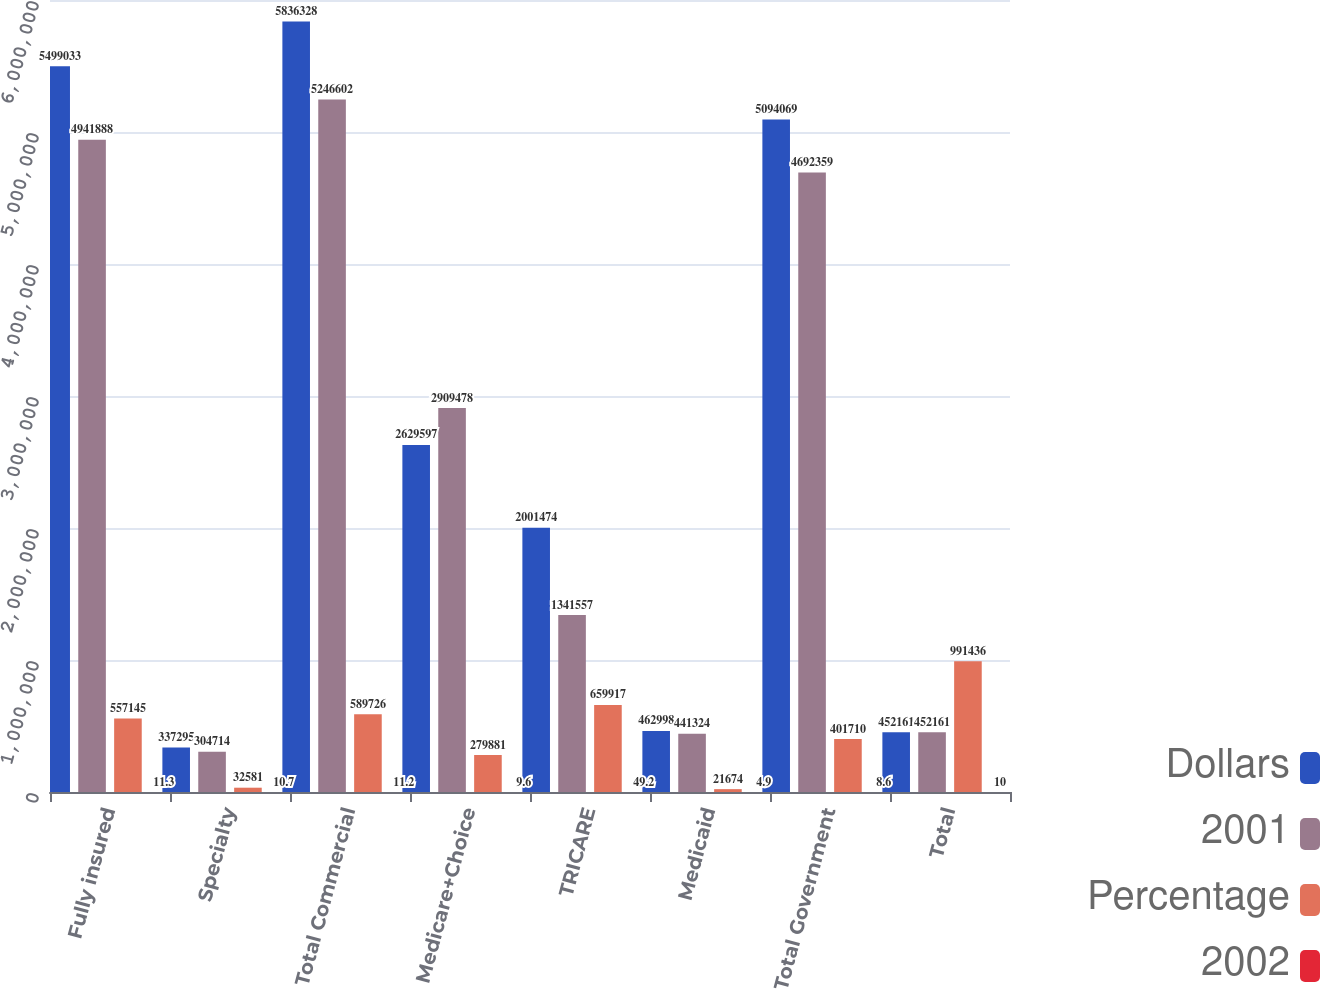Convert chart. <chart><loc_0><loc_0><loc_500><loc_500><stacked_bar_chart><ecel><fcel>Fully insured<fcel>Specialty<fcel>Total Commercial<fcel>Medicare+Choice<fcel>TRICARE<fcel>Medicaid<fcel>Total Government<fcel>Total<nl><fcel>Dollars<fcel>5.49903e+06<fcel>337295<fcel>5.83633e+06<fcel>2.6296e+06<fcel>2.00147e+06<fcel>462998<fcel>5.09407e+06<fcel>452161<nl><fcel>2001<fcel>4.94189e+06<fcel>304714<fcel>5.2466e+06<fcel>2.90948e+06<fcel>1.34156e+06<fcel>441324<fcel>4.69236e+06<fcel>452161<nl><fcel>Percentage<fcel>557145<fcel>32581<fcel>589726<fcel>279881<fcel>659917<fcel>21674<fcel>401710<fcel>991436<nl><fcel>2002<fcel>11.3<fcel>10.7<fcel>11.2<fcel>9.6<fcel>49.2<fcel>4.9<fcel>8.6<fcel>10<nl></chart> 